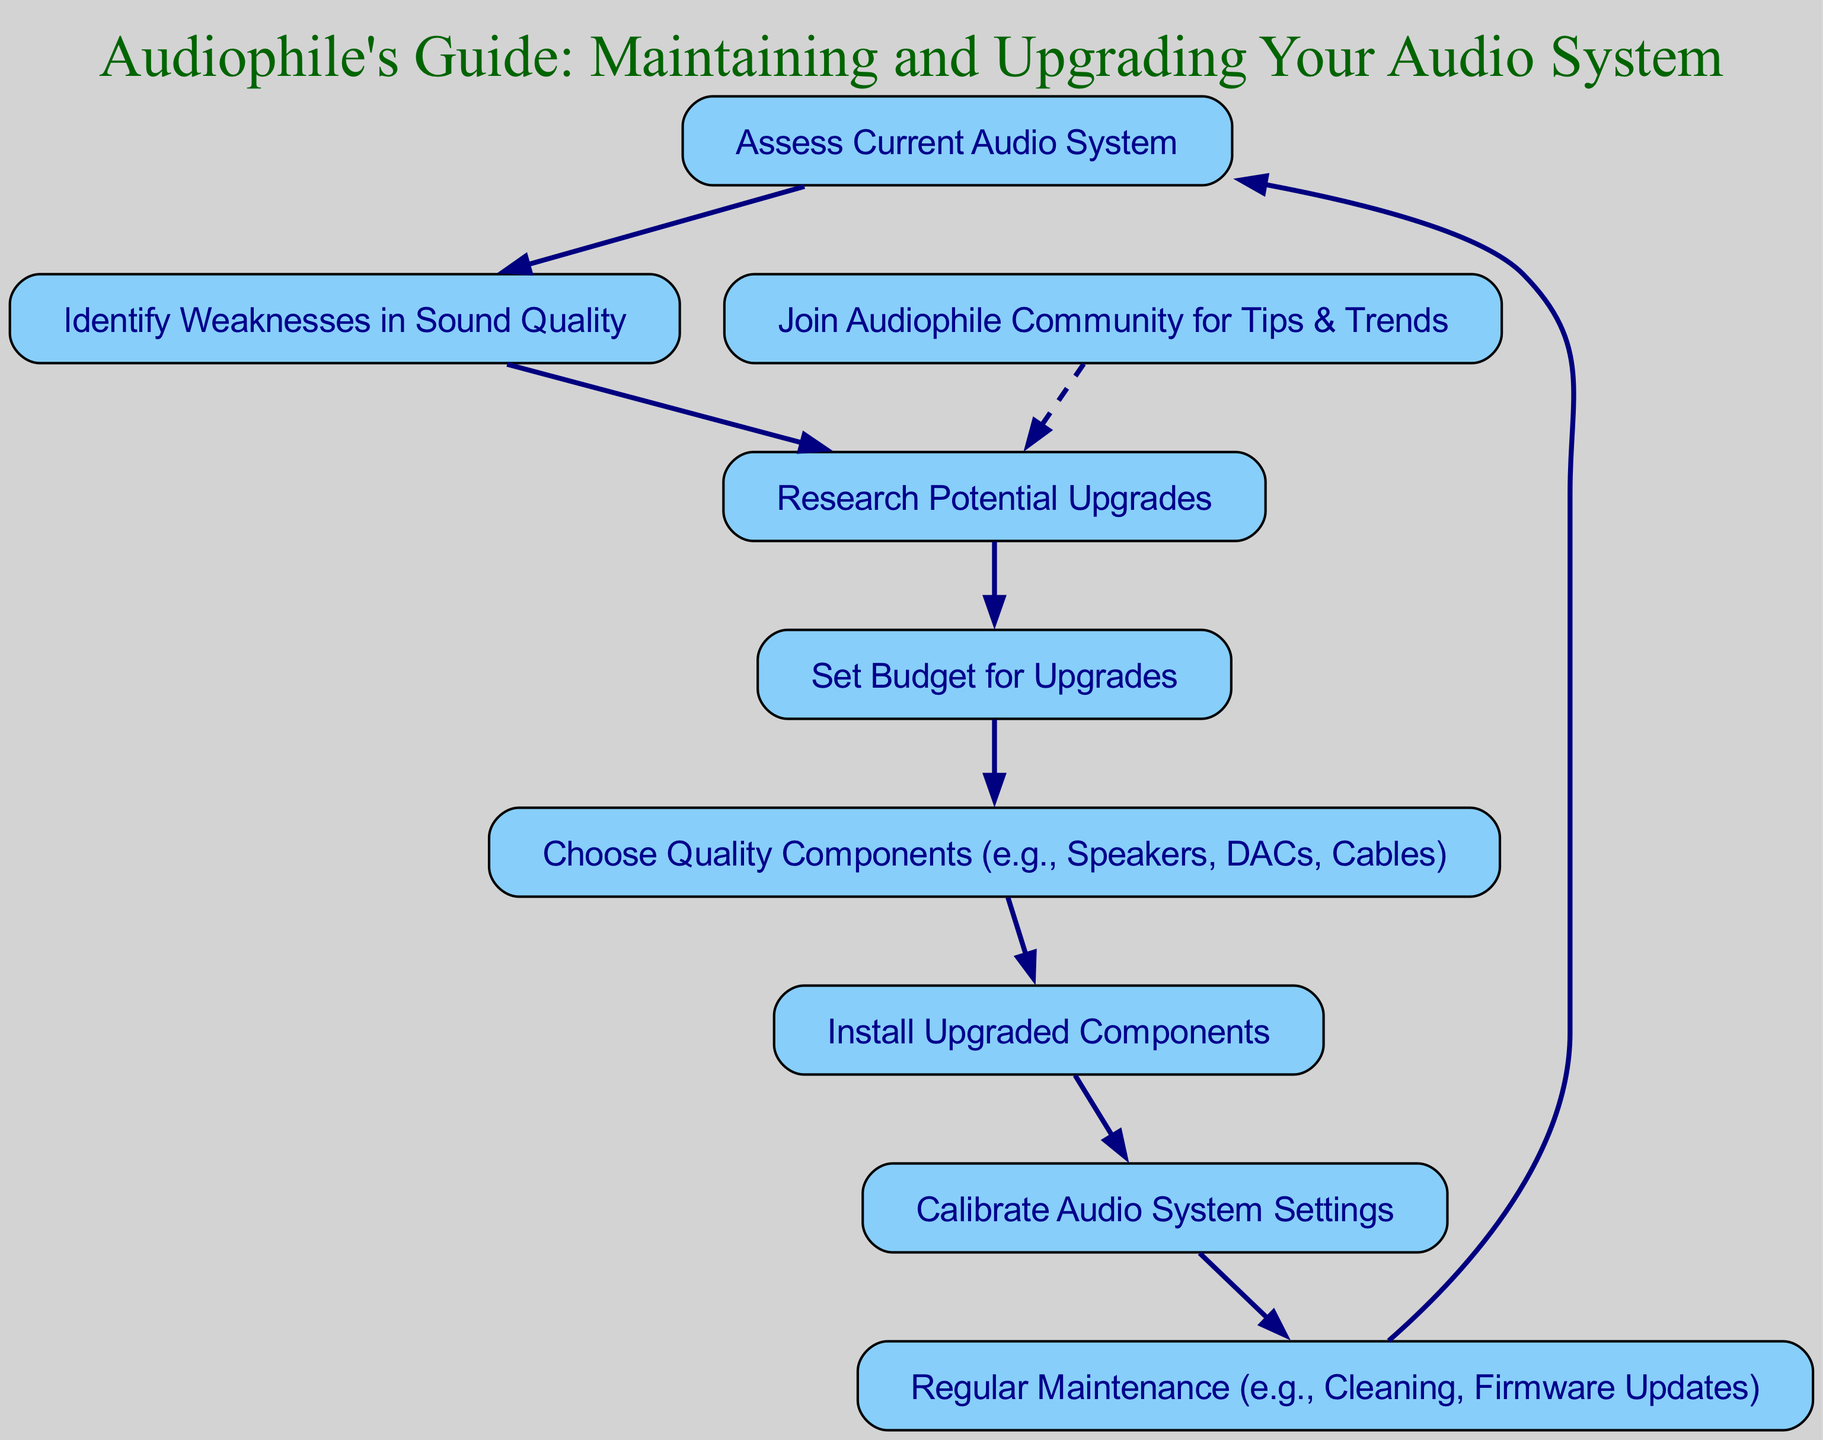What is the first step in the flow chart? The first step in the flow chart is "Assess Current Audio System". This is evident as it is the starting node from which all other nodes branch out.
Answer: Assess Current Audio System How many nodes are present in this flow chart? The diagram includes 9 nodes total, which can be counted from the listing of different steps involved in maintaining and upgrading the audio system.
Answer: 9 What might you do after "Choose Quality Components"? The step that follows "Choose Quality Components" is "Install Upgraded Components". This indicates the process that comes directly after selecting the components.
Answer: Install Upgraded Components What is the relationship between "Join Audiophile Community" and "Research Potential Upgrades"? "Join Audiophile Community" has a dashed edge leading to "Research Potential Upgrades", implying that joining the community can provide tips that may assist in researching upgrades.
Answer: Tips for upgrades What is the last step in this flow chart? The flow chart concludes with "Regular Maintenance", which connects back to "Assess Current Audio System", indicating the cyclical nature of the maintenance process.
Answer: Regular Maintenance After "Calibrate Audio System Settings", what comes next? Following "Calibrate Audio System Settings", the next action is "Regular Maintenance". This suggests that calibration is part of broader ongoing maintenance activities.
Answer: Regular Maintenance How is "Identify Weaknesses in Sound Quality" related to "Assess Current Audio System"? "Identify Weaknesses in Sound Quality" directly follows "Assess Current Audio System", representing a sequential step in the process of evaluating the audio system.
Answer: Directly follows Which step involves setting a financial limit for upgrades? The step titled "Set Budget for Upgrades" is specifically where one determines how much money they are willing to spend on audio system enhancements.
Answer: Set Budget for Upgrades What is indicated by the dashed line in the flow chart? The dashed line indicates an optional or supplementary action; in this case, it shows that joining an audiophile community serves as a way to gather additional information for research on upgrades.
Answer: Gather additional information 